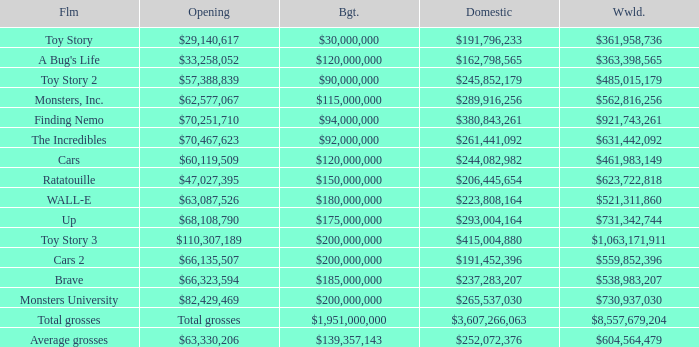WHAT IS THE WORLDWIDE BOX OFFICE FOR BRAVE? $538,983,207. 